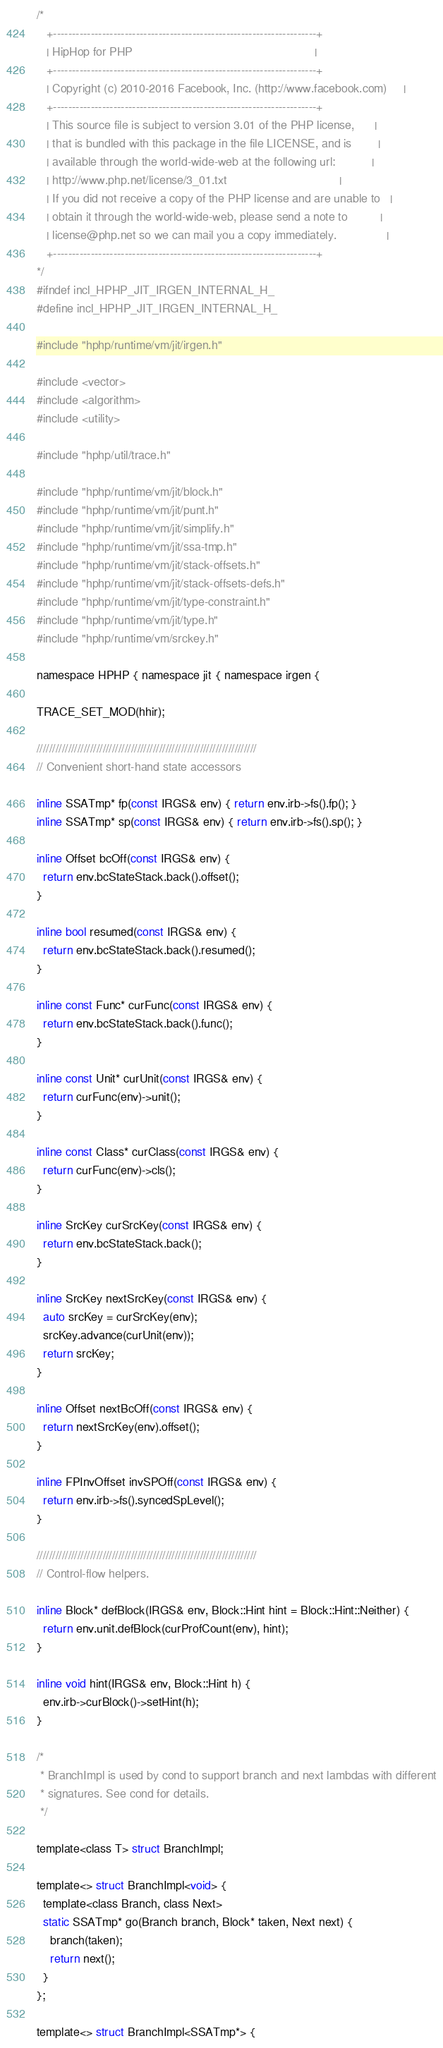<code> <loc_0><loc_0><loc_500><loc_500><_C_>/*
   +----------------------------------------------------------------------+
   | HipHop for PHP                                                       |
   +----------------------------------------------------------------------+
   | Copyright (c) 2010-2016 Facebook, Inc. (http://www.facebook.com)     |
   +----------------------------------------------------------------------+
   | This source file is subject to version 3.01 of the PHP license,      |
   | that is bundled with this package in the file LICENSE, and is        |
   | available through the world-wide-web at the following url:           |
   | http://www.php.net/license/3_01.txt                                  |
   | If you did not receive a copy of the PHP license and are unable to   |
   | obtain it through the world-wide-web, please send a note to          |
   | license@php.net so we can mail you a copy immediately.               |
   +----------------------------------------------------------------------+
*/
#ifndef incl_HPHP_JIT_IRGEN_INTERNAL_H_
#define incl_HPHP_JIT_IRGEN_INTERNAL_H_

#include "hphp/runtime/vm/jit/irgen.h"

#include <vector>
#include <algorithm>
#include <utility>

#include "hphp/util/trace.h"

#include "hphp/runtime/vm/jit/block.h"
#include "hphp/runtime/vm/jit/punt.h"
#include "hphp/runtime/vm/jit/simplify.h"
#include "hphp/runtime/vm/jit/ssa-tmp.h"
#include "hphp/runtime/vm/jit/stack-offsets.h"
#include "hphp/runtime/vm/jit/stack-offsets-defs.h"
#include "hphp/runtime/vm/jit/type-constraint.h"
#include "hphp/runtime/vm/jit/type.h"
#include "hphp/runtime/vm/srckey.h"

namespace HPHP { namespace jit { namespace irgen {

TRACE_SET_MOD(hhir);

//////////////////////////////////////////////////////////////////////
// Convenient short-hand state accessors

inline SSATmp* fp(const IRGS& env) { return env.irb->fs().fp(); }
inline SSATmp* sp(const IRGS& env) { return env.irb->fs().sp(); }

inline Offset bcOff(const IRGS& env) {
  return env.bcStateStack.back().offset();
}

inline bool resumed(const IRGS& env) {
  return env.bcStateStack.back().resumed();
}

inline const Func* curFunc(const IRGS& env) {
  return env.bcStateStack.back().func();
}

inline const Unit* curUnit(const IRGS& env) {
  return curFunc(env)->unit();
}

inline const Class* curClass(const IRGS& env) {
  return curFunc(env)->cls();
}

inline SrcKey curSrcKey(const IRGS& env) {
  return env.bcStateStack.back();
}

inline SrcKey nextSrcKey(const IRGS& env) {
  auto srcKey = curSrcKey(env);
  srcKey.advance(curUnit(env));
  return srcKey;
}

inline Offset nextBcOff(const IRGS& env) {
  return nextSrcKey(env).offset();
}

inline FPInvOffset invSPOff(const IRGS& env) {
  return env.irb->fs().syncedSpLevel();
}

//////////////////////////////////////////////////////////////////////
// Control-flow helpers.

inline Block* defBlock(IRGS& env, Block::Hint hint = Block::Hint::Neither) {
  return env.unit.defBlock(curProfCount(env), hint);
}

inline void hint(IRGS& env, Block::Hint h) {
  env.irb->curBlock()->setHint(h);
}

/*
 * BranchImpl is used by cond to support branch and next lambdas with different
 * signatures. See cond for details.
 */

template<class T> struct BranchImpl;

template<> struct BranchImpl<void> {
  template<class Branch, class Next>
  static SSATmp* go(Branch branch, Block* taken, Next next) {
    branch(taken);
    return next();
  }
};

template<> struct BranchImpl<SSATmp*> {</code> 